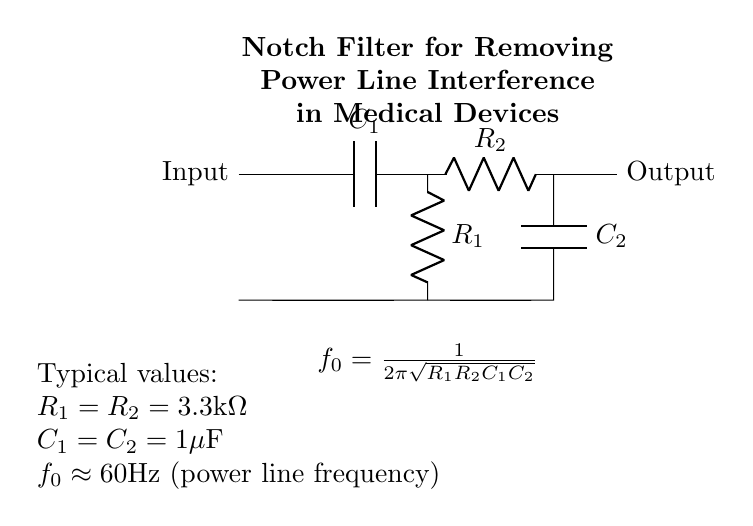What type of filter is represented in the diagram? The circuit diagram illustrates a notch filter, which is specifically designed to attenuate a particular frequency while allowing others to pass through. This is evident from the design structure and its purpose stated in the title.
Answer: Notch filter What is the purpose of this notch filter? This notch filter is designed to remove power line interference, typically centered around 60Hz, which can affect the performance of medical devices. The title indicates its application directly in medical contexts.
Answer: Remove power line interference What are the values of the resistors used in the circuit? Both resistors in the circuit, R1 and R2, are labeled with the same value of 3.3 kilo-ohms as stated in the component values section. This uniformity is common in notch filters for symmetry.
Answer: 3.3 kilo-ohms What is the value of the capacitors used in the circuit? Similarly, both capacitors, C1 and C2, are valued at 1 microfarad, indicating that the filter uses the same capacitor values to maintain uniform resonance characteristics, as shown in the notes beneath the circuit.
Answer: 1 microfarad How can the center frequency of the notch filter be calculated? The center frequency, f0, can be calculated using the formula provided in the diagram: f0 = 1/(2*pi*sqrt(R1*R2*C1*C2)). By substituting the given values of R1, R2, C1, and C2 into this formula, one can determine the frequency at which interference is attenuated. This step requires recognizing the role of R and C values in the frequency response of filters.
Answer: 60 Hertz What happens to frequencies close to 60 Hertz? Frequencies close to 60 Hertz will be significantly attenuated by the notch filter due to its design to block that specific frequency. The configuration of the resistors and capacitors creates a frequency response that has a sharp dip at the center frequency, which is used to remove unwanted noise from the signal.
Answer: Attenuated significantly What does the notation in the diagram indicate about component values? The notation displays typical component values for R1, R2, C1, and C2 directly beneath the circuit, providing designers with a quick reference for commonly used values that effectively achieve the notch filter's intended frequency response. This informs users of standard components that can be used in practical applications of the design.
Answer: Typical values noted 